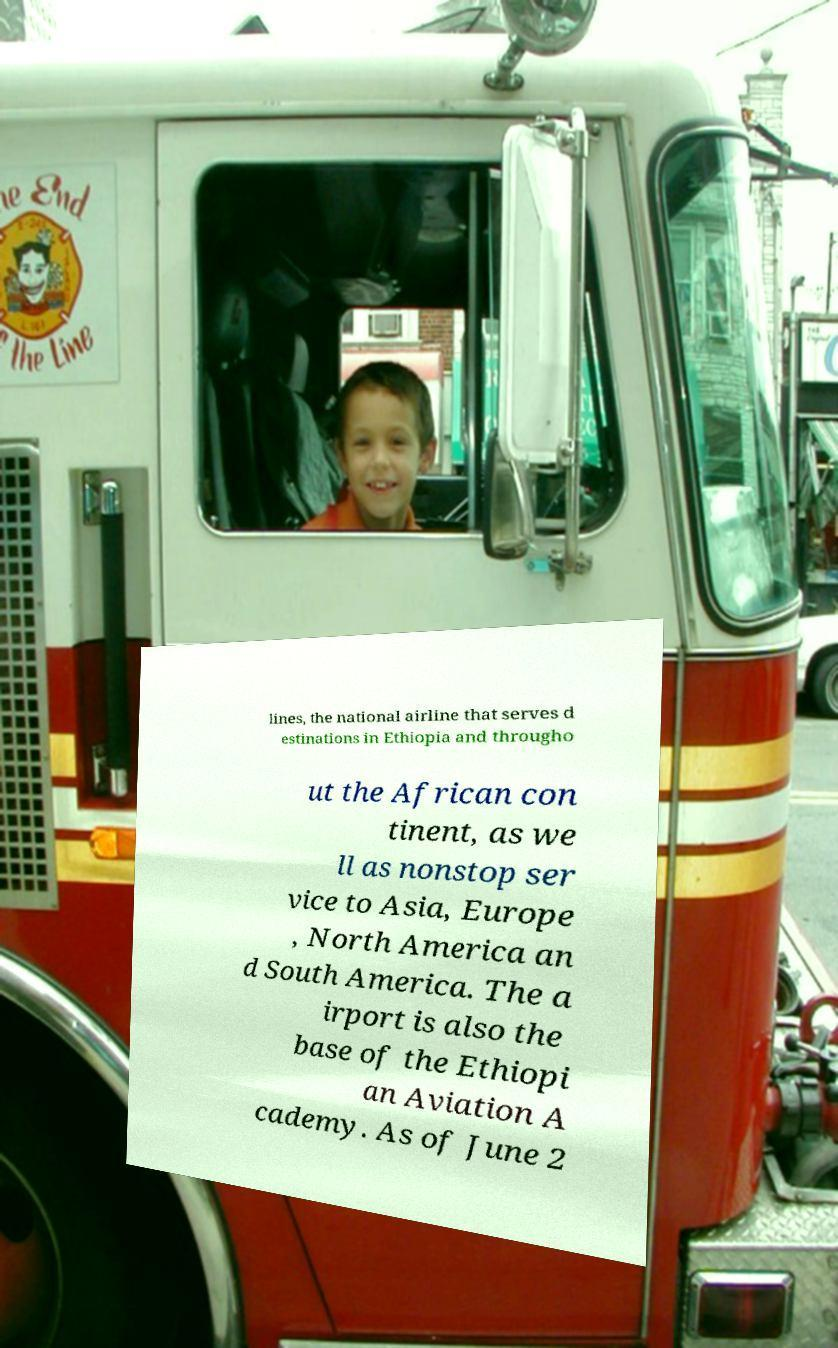What messages or text are displayed in this image? I need them in a readable, typed format. lines, the national airline that serves d estinations in Ethiopia and througho ut the African con tinent, as we ll as nonstop ser vice to Asia, Europe , North America an d South America. The a irport is also the base of the Ethiopi an Aviation A cademy. As of June 2 